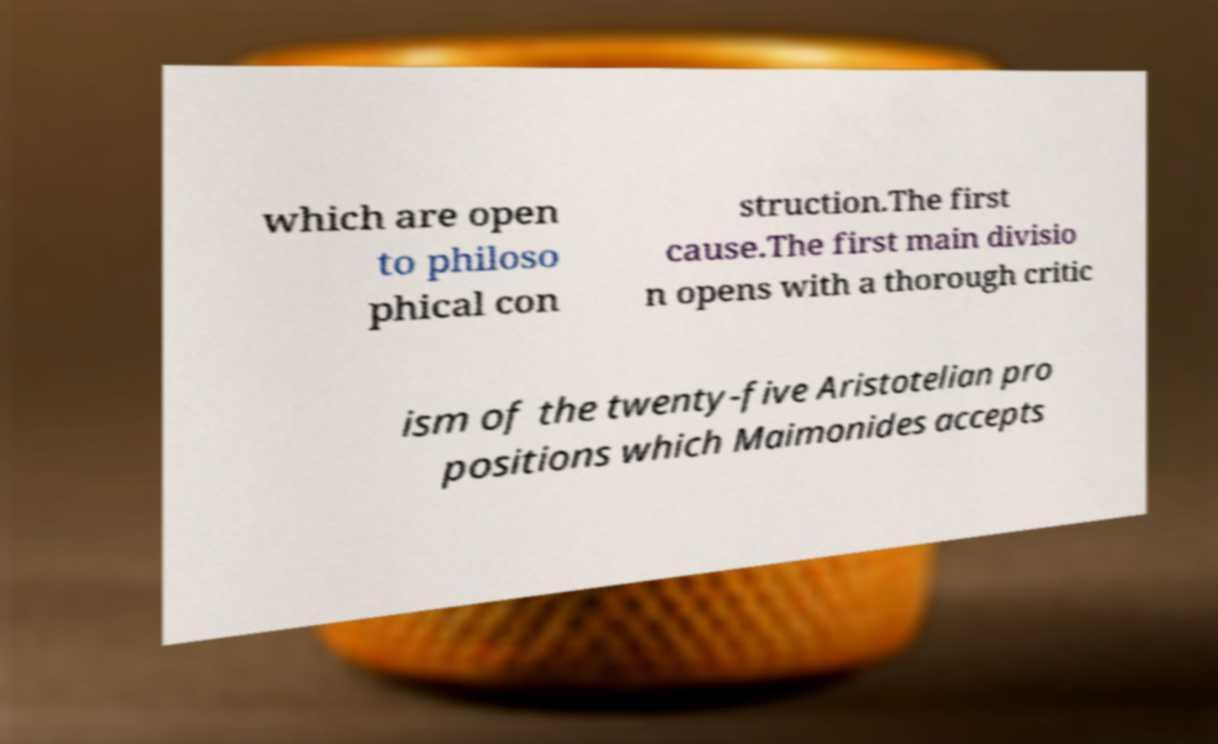Can you read and provide the text displayed in the image?This photo seems to have some interesting text. Can you extract and type it out for me? which are open to philoso phical con struction.The first cause.The first main divisio n opens with a thorough critic ism of the twenty-five Aristotelian pro positions which Maimonides accepts 